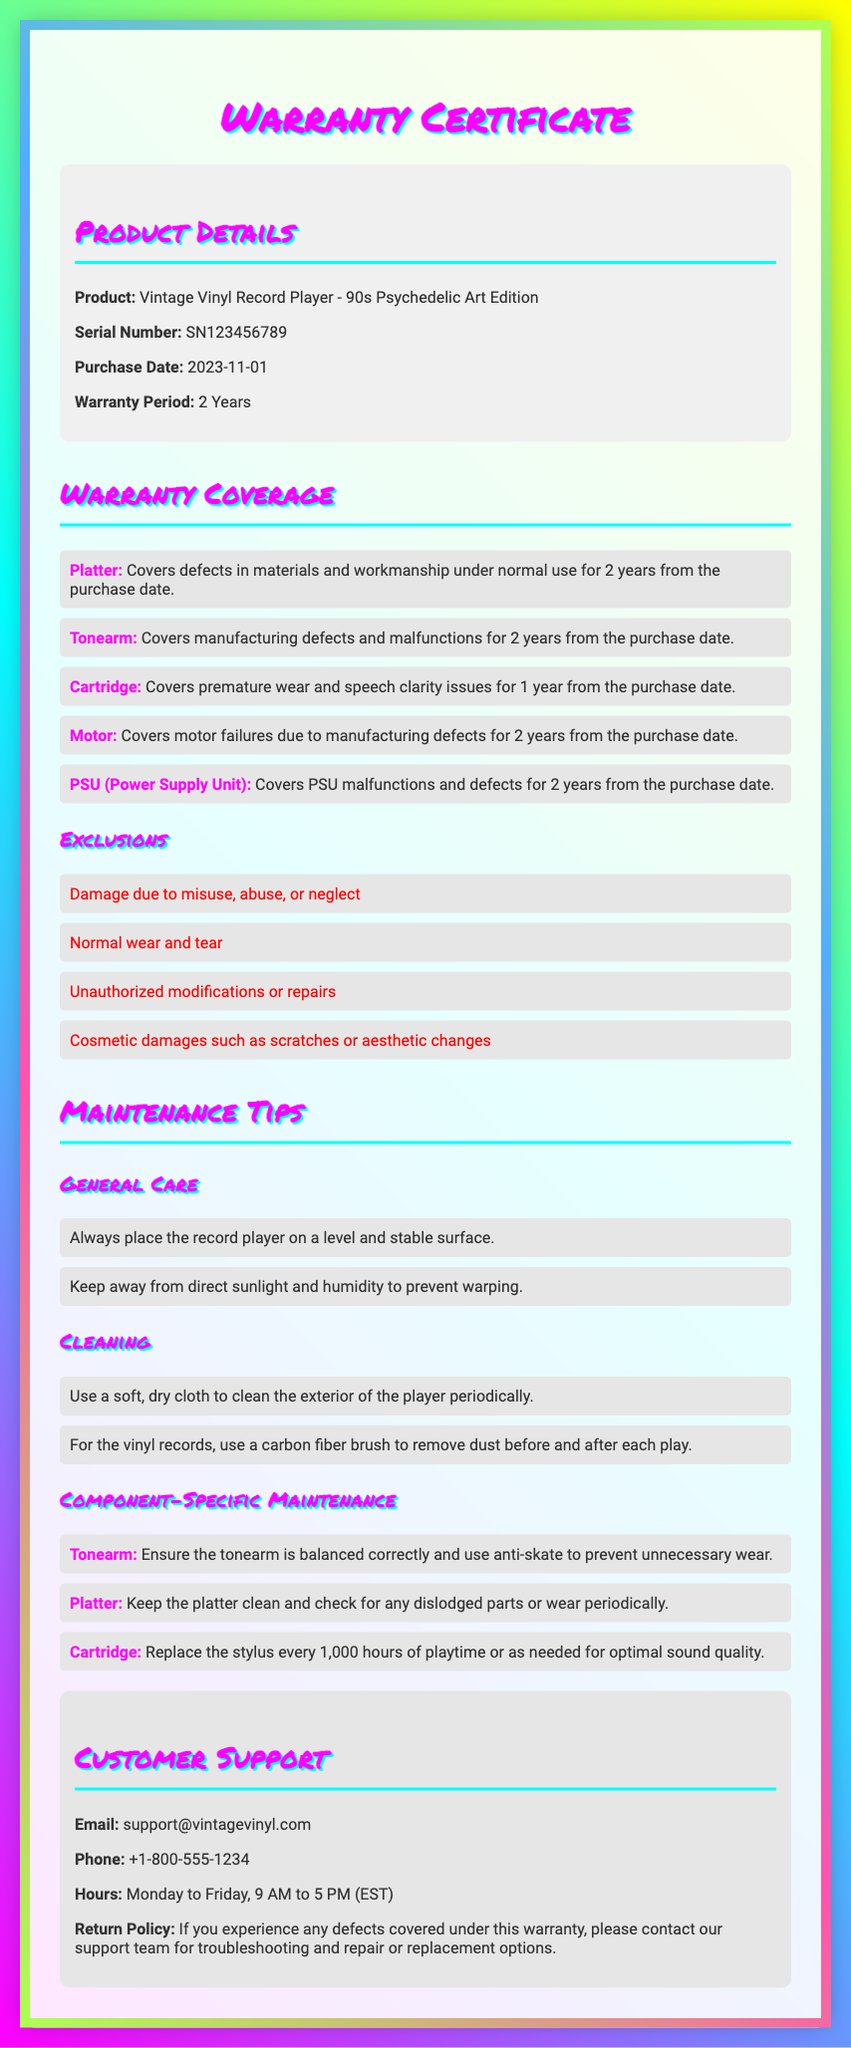What is the warranty period for the vintage vinyl record player? The warranty period is mentioned in the product details section of the document, which states that it is 2 years from the purchase date.
Answer: 2 Years What is the serial number of the product? The serial number is listed under the product details section in the document.
Answer: SN123456789 What type of defects does the warranty cover for the motor? The coverage section outlines that it covers motor failures due to manufacturing defects.
Answer: Manufacturing defects Which component has a coverage duration of 1 year? The coverage section specifies that the cartridge covers premature wear and speech clarity issues for 1 year.
Answer: Cartridge What are customers advised to keep the record player away from? The maintenance tips advise keeping the player away from direct sunlight and humidity.
Answer: Direct sunlight and humidity What should you use to clean vinyl records? The maintenance section recommends using a carbon fiber brush to remove dust before and after each play.
Answer: Carbon fiber brush What actions are excluded from warranty coverage? The exclusions section lists damage due to misuse, normal wear and tear, and unauthorized modifications among others.
Answer: Misuse, normal wear and tear, unauthorized modifications What is the return policy according to the document? The return policy section specifies that customers should contact support for troubleshooting and repair or replacement if defects covered under the warranty are experienced.
Answer: Contact support for troubleshooting and repair 